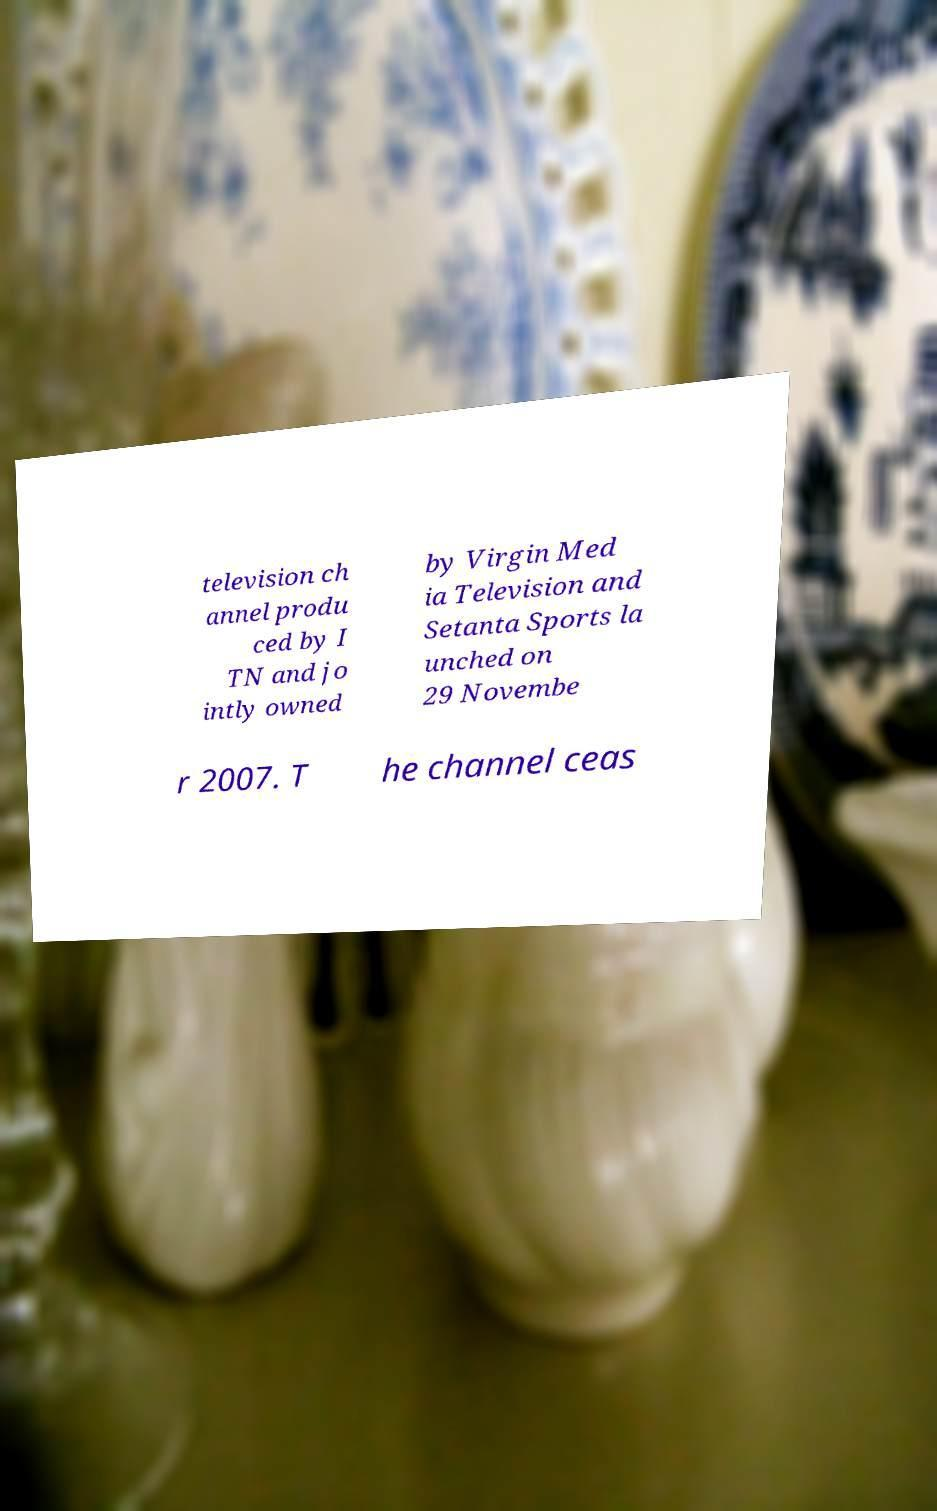What messages or text are displayed in this image? I need them in a readable, typed format. television ch annel produ ced by I TN and jo intly owned by Virgin Med ia Television and Setanta Sports la unched on 29 Novembe r 2007. T he channel ceas 